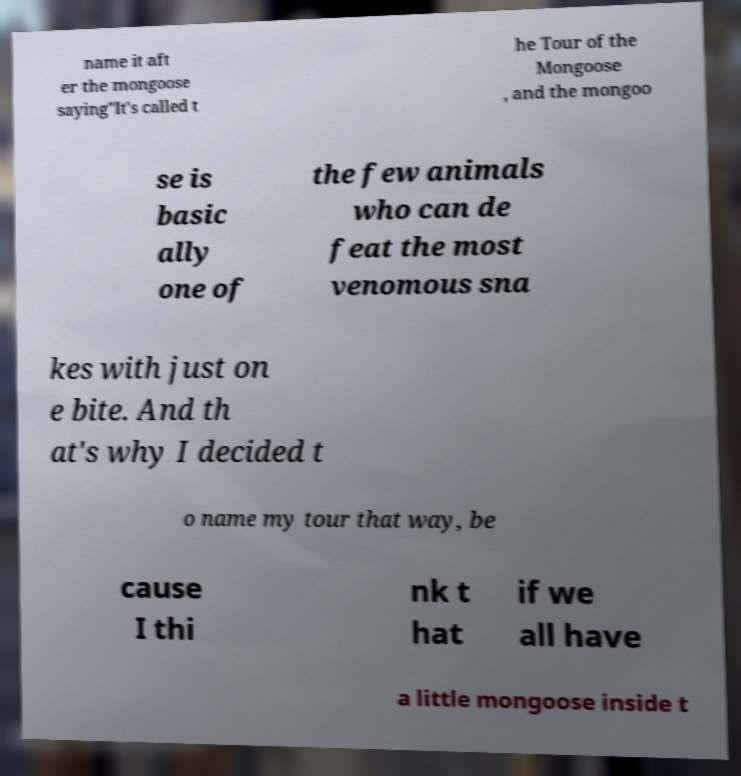Please read and relay the text visible in this image. What does it say? name it aft er the mongoose saying"It's called t he Tour of the Mongoose , and the mongoo se is basic ally one of the few animals who can de feat the most venomous sna kes with just on e bite. And th at's why I decided t o name my tour that way, be cause I thi nk t hat if we all have a little mongoose inside t 